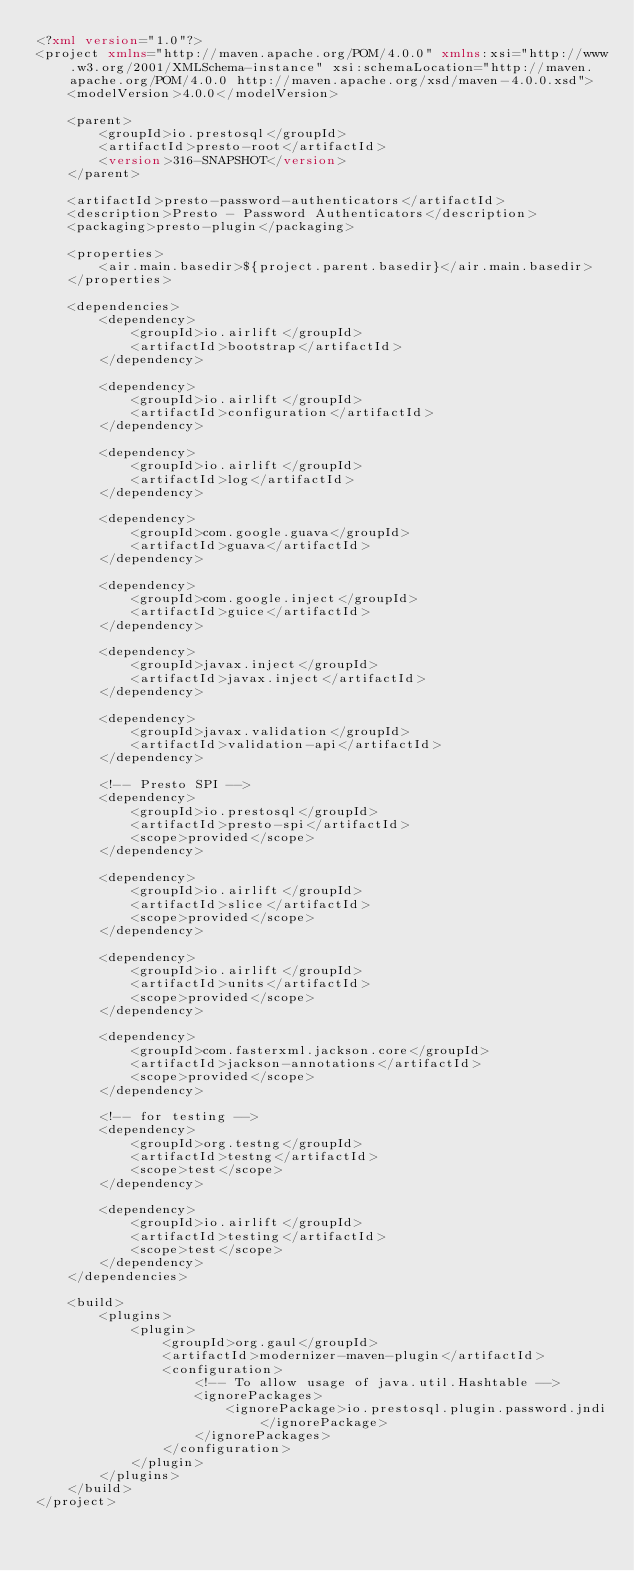Convert code to text. <code><loc_0><loc_0><loc_500><loc_500><_XML_><?xml version="1.0"?>
<project xmlns="http://maven.apache.org/POM/4.0.0" xmlns:xsi="http://www.w3.org/2001/XMLSchema-instance" xsi:schemaLocation="http://maven.apache.org/POM/4.0.0 http://maven.apache.org/xsd/maven-4.0.0.xsd">
    <modelVersion>4.0.0</modelVersion>

    <parent>
        <groupId>io.prestosql</groupId>
        <artifactId>presto-root</artifactId>
        <version>316-SNAPSHOT</version>
    </parent>

    <artifactId>presto-password-authenticators</artifactId>
    <description>Presto - Password Authenticators</description>
    <packaging>presto-plugin</packaging>

    <properties>
        <air.main.basedir>${project.parent.basedir}</air.main.basedir>
    </properties>

    <dependencies>
        <dependency>
            <groupId>io.airlift</groupId>
            <artifactId>bootstrap</artifactId>
        </dependency>

        <dependency>
            <groupId>io.airlift</groupId>
            <artifactId>configuration</artifactId>
        </dependency>

        <dependency>
            <groupId>io.airlift</groupId>
            <artifactId>log</artifactId>
        </dependency>

        <dependency>
            <groupId>com.google.guava</groupId>
            <artifactId>guava</artifactId>
        </dependency>

        <dependency>
            <groupId>com.google.inject</groupId>
            <artifactId>guice</artifactId>
        </dependency>

        <dependency>
            <groupId>javax.inject</groupId>
            <artifactId>javax.inject</artifactId>
        </dependency>

        <dependency>
            <groupId>javax.validation</groupId>
            <artifactId>validation-api</artifactId>
        </dependency>

        <!-- Presto SPI -->
        <dependency>
            <groupId>io.prestosql</groupId>
            <artifactId>presto-spi</artifactId>
            <scope>provided</scope>
        </dependency>

        <dependency>
            <groupId>io.airlift</groupId>
            <artifactId>slice</artifactId>
            <scope>provided</scope>
        </dependency>

        <dependency>
            <groupId>io.airlift</groupId>
            <artifactId>units</artifactId>
            <scope>provided</scope>
        </dependency>

        <dependency>
            <groupId>com.fasterxml.jackson.core</groupId>
            <artifactId>jackson-annotations</artifactId>
            <scope>provided</scope>
        </dependency>

        <!-- for testing -->
        <dependency>
            <groupId>org.testng</groupId>
            <artifactId>testng</artifactId>
            <scope>test</scope>
        </dependency>

        <dependency>
            <groupId>io.airlift</groupId>
            <artifactId>testing</artifactId>
            <scope>test</scope>
        </dependency>
    </dependencies>

    <build>
        <plugins>
            <plugin>
                <groupId>org.gaul</groupId>
                <artifactId>modernizer-maven-plugin</artifactId>
                <configuration>
                    <!-- To allow usage of java.util.Hashtable -->
                    <ignorePackages>
                        <ignorePackage>io.prestosql.plugin.password.jndi</ignorePackage>
                    </ignorePackages>
                </configuration>
            </plugin>
        </plugins>
    </build>
</project>
</code> 